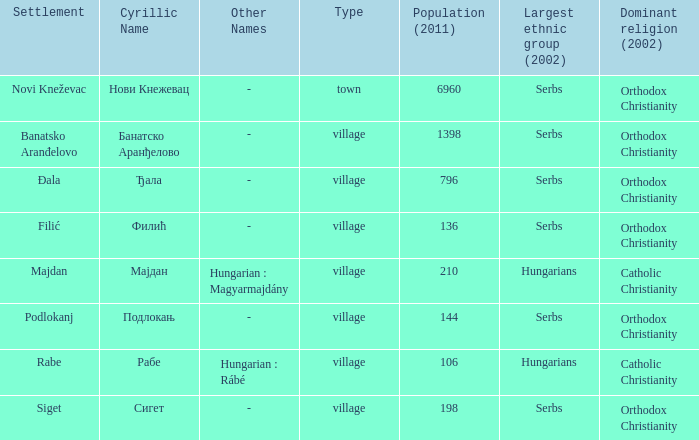What is rabe called in cyrillic and what is its other name? Рабе ( Hungarian : Rábé ). 